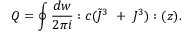Convert formula to latex. <formula><loc_0><loc_0><loc_500><loc_500>Q = \oint { \frac { d w } { 2 \pi i } } \colon c ( \tilde { J } ^ { 3 } + J ^ { 3 } ) \colon ( z ) .</formula> 